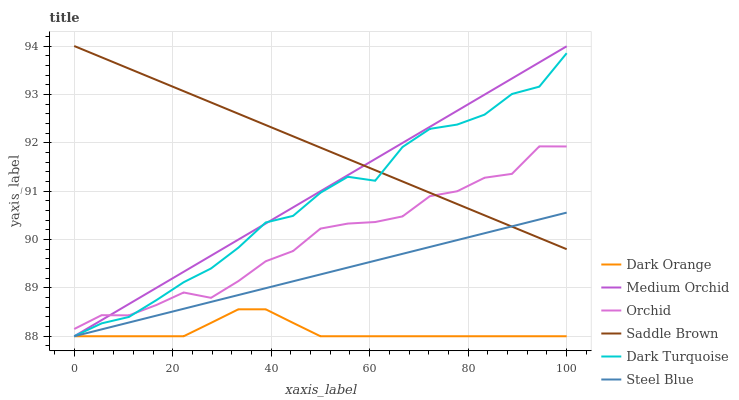Does Dark Orange have the minimum area under the curve?
Answer yes or no. Yes. Does Saddle Brown have the maximum area under the curve?
Answer yes or no. Yes. Does Dark Turquoise have the minimum area under the curve?
Answer yes or no. No. Does Dark Turquoise have the maximum area under the curve?
Answer yes or no. No. Is Medium Orchid the smoothest?
Answer yes or no. Yes. Is Dark Turquoise the roughest?
Answer yes or no. Yes. Is Dark Turquoise the smoothest?
Answer yes or no. No. Is Medium Orchid the roughest?
Answer yes or no. No. Does Dark Orange have the lowest value?
Answer yes or no. Yes. Does Saddle Brown have the lowest value?
Answer yes or no. No. Does Saddle Brown have the highest value?
Answer yes or no. Yes. Does Dark Turquoise have the highest value?
Answer yes or no. No. Is Dark Orange less than Orchid?
Answer yes or no. Yes. Is Orchid greater than Steel Blue?
Answer yes or no. Yes. Does Dark Turquoise intersect Steel Blue?
Answer yes or no. Yes. Is Dark Turquoise less than Steel Blue?
Answer yes or no. No. Is Dark Turquoise greater than Steel Blue?
Answer yes or no. No. Does Dark Orange intersect Orchid?
Answer yes or no. No. 